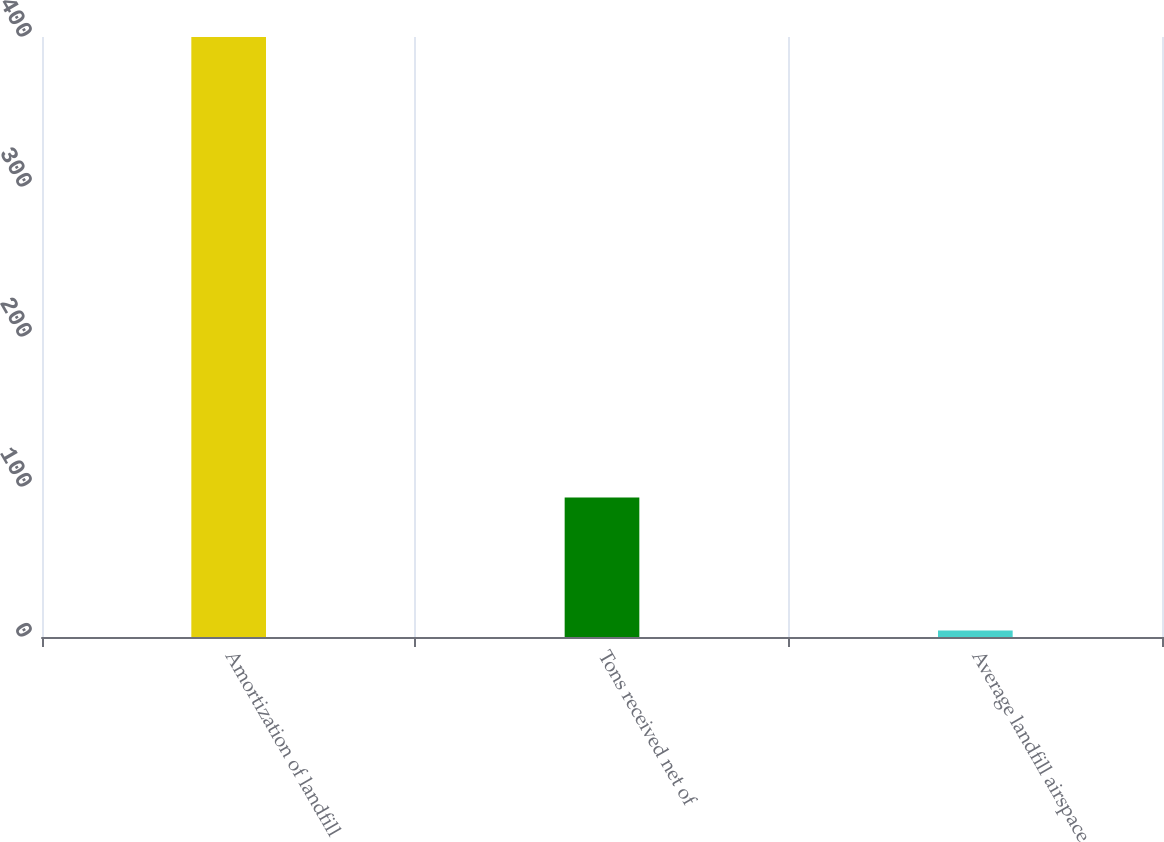Convert chart. <chart><loc_0><loc_0><loc_500><loc_500><bar_chart><fcel>Amortization of landfill<fcel>Tons received net of<fcel>Average landfill airspace<nl><fcel>400<fcel>93<fcel>4.29<nl></chart> 